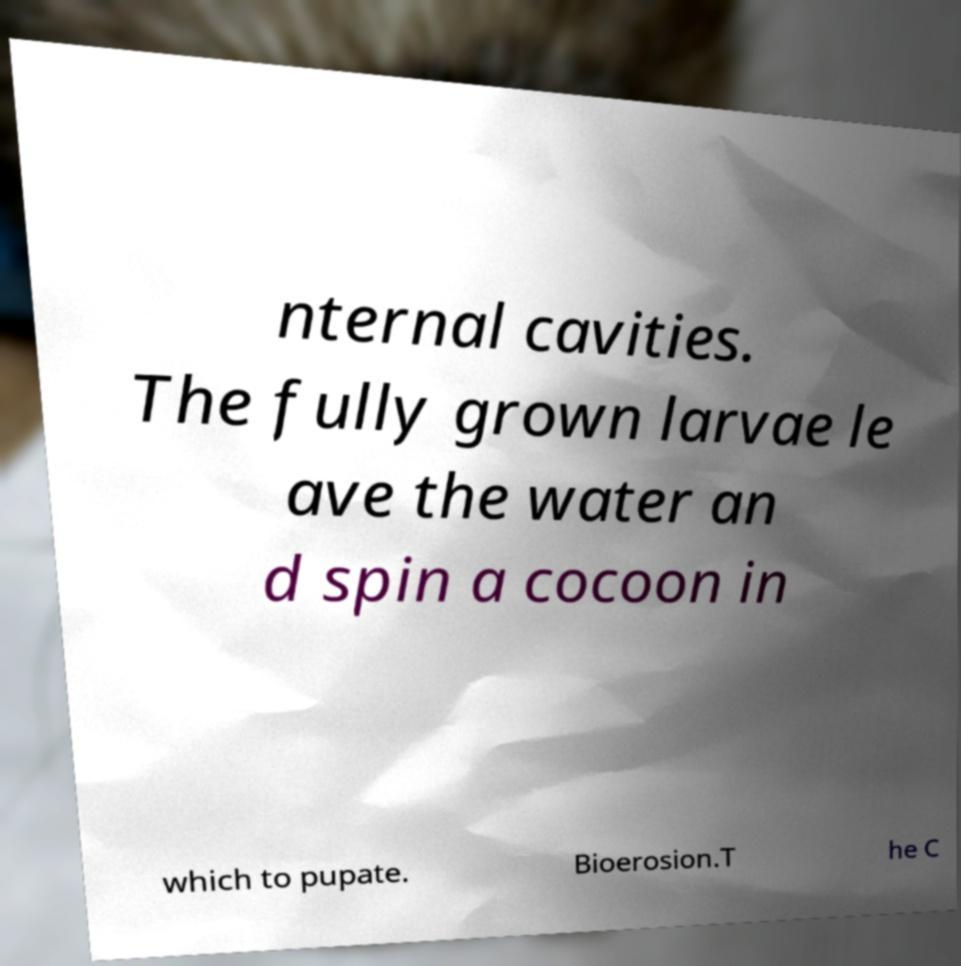Can you read and provide the text displayed in the image?This photo seems to have some interesting text. Can you extract and type it out for me? nternal cavities. The fully grown larvae le ave the water an d spin a cocoon in which to pupate. Bioerosion.T he C 